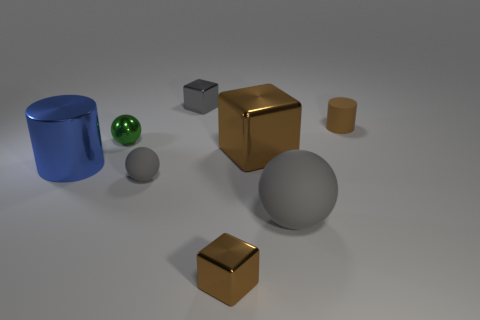Add 1 tiny brown cubes. How many objects exist? 9 Subtract all cylinders. How many objects are left? 6 Subtract 0 red cylinders. How many objects are left? 8 Subtract all gray balls. Subtract all big metal objects. How many objects are left? 4 Add 7 brown cylinders. How many brown cylinders are left? 8 Add 5 tiny cylinders. How many tiny cylinders exist? 6 